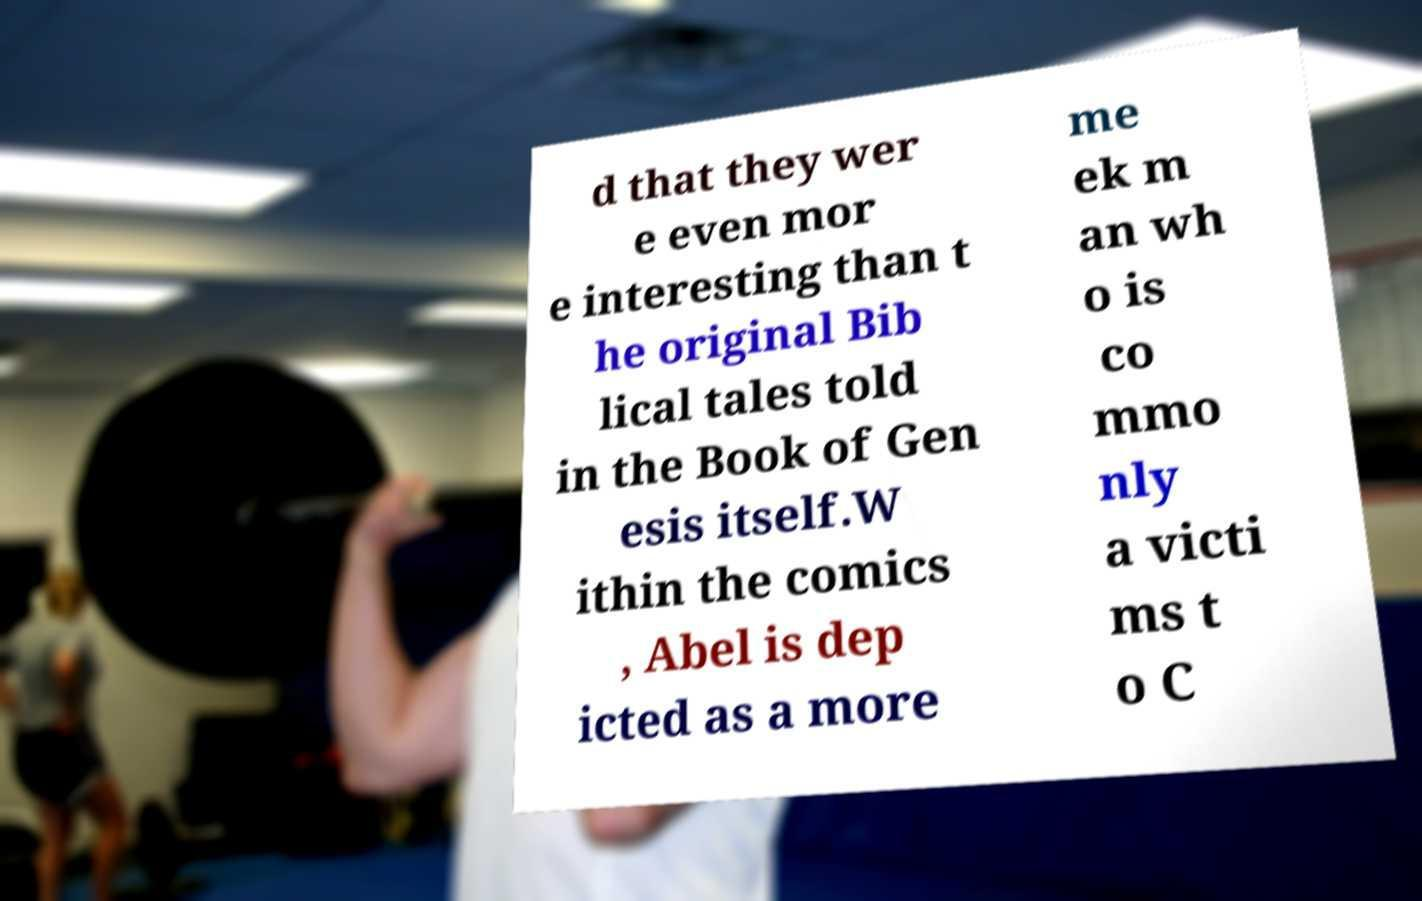There's text embedded in this image that I need extracted. Can you transcribe it verbatim? d that they wer e even mor e interesting than t he original Bib lical tales told in the Book of Gen esis itself.W ithin the comics , Abel is dep icted as a more me ek m an wh o is co mmo nly a victi ms t o C 